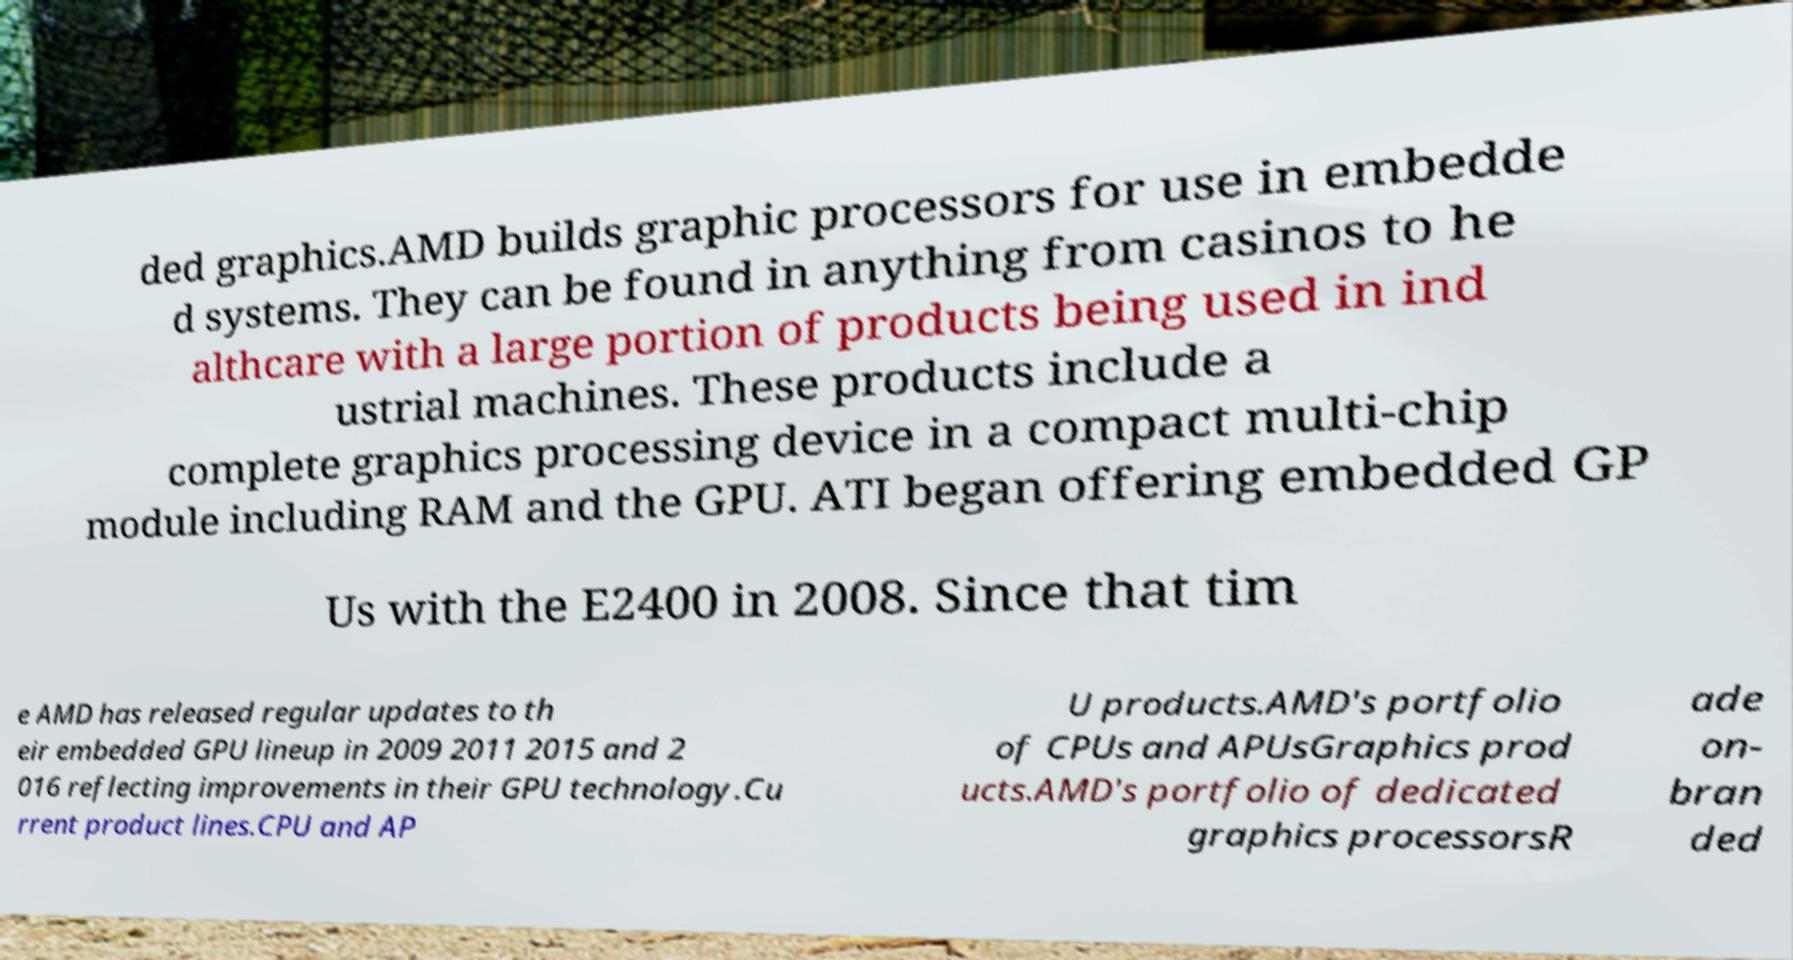Could you assist in decoding the text presented in this image and type it out clearly? ded graphics.AMD builds graphic processors for use in embedde d systems. They can be found in anything from casinos to he althcare with a large portion of products being used in ind ustrial machines. These products include a complete graphics processing device in a compact multi-chip module including RAM and the GPU. ATI began offering embedded GP Us with the E2400 in 2008. Since that tim e AMD has released regular updates to th eir embedded GPU lineup in 2009 2011 2015 and 2 016 reflecting improvements in their GPU technology.Cu rrent product lines.CPU and AP U products.AMD's portfolio of CPUs and APUsGraphics prod ucts.AMD's portfolio of dedicated graphics processorsR ade on- bran ded 